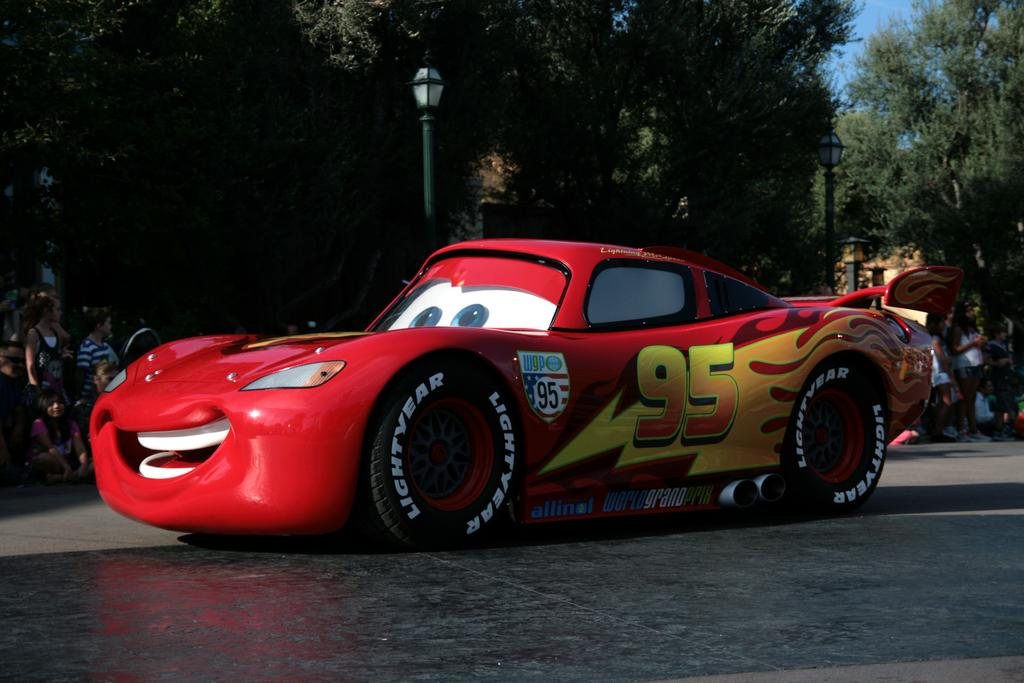What is the main subject in the foreground of the picture? There is a car in the foreground of the picture. What can be seen in the center of the picture? There are people, trees, and a street light in the center of the picture. What is the weather like on this sunny day? It is a sunny day, which suggests clear skies and good visibility. What type of bead is being used to create the title of the image? There is no bead or title present in the image; it is a photograph of a car, people, trees, and a street light on a sunny day. 